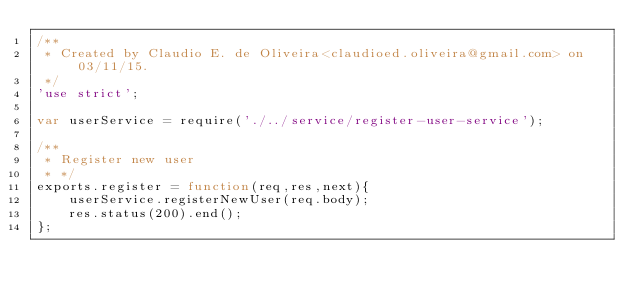<code> <loc_0><loc_0><loc_500><loc_500><_JavaScript_>/**
 * Created by Claudio E. de Oliveira<claudioed.oliveira@gmail.com> on 03/11/15.
 */
'use strict';

var userService = require('./../service/register-user-service');

/**
 * Register new user
 * */
exports.register = function(req,res,next){
    userService.registerNewUser(req.body);
    res.status(200).end();
};</code> 